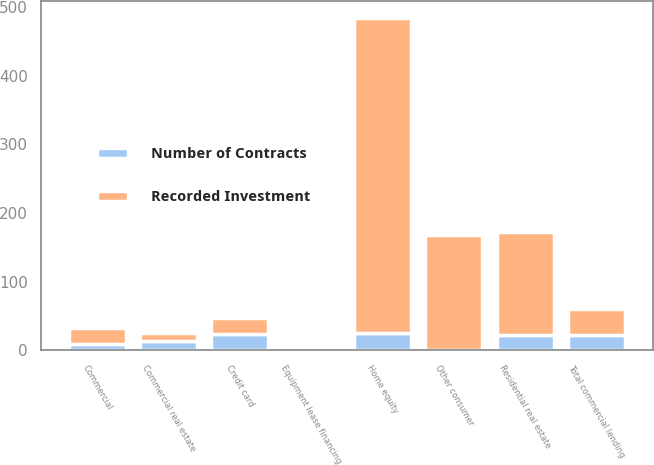Convert chart to OTSL. <chart><loc_0><loc_0><loc_500><loc_500><stacked_bar_chart><ecel><fcel>Commercial<fcel>Commercial real estate<fcel>Equipment lease financing<fcel>Total commercial lending<fcel>Home equity<fcel>Residential real estate<fcel>Credit card<fcel>Other consumer<nl><fcel>Recorded Investment<fcel>23<fcel>13<fcel>1<fcel>37<fcel>458<fcel>150<fcel>23<fcel>167<nl><fcel>Number of Contracts<fcel>9<fcel>13<fcel>1<fcel>23<fcel>26<fcel>22<fcel>24<fcel>1<nl></chart> 